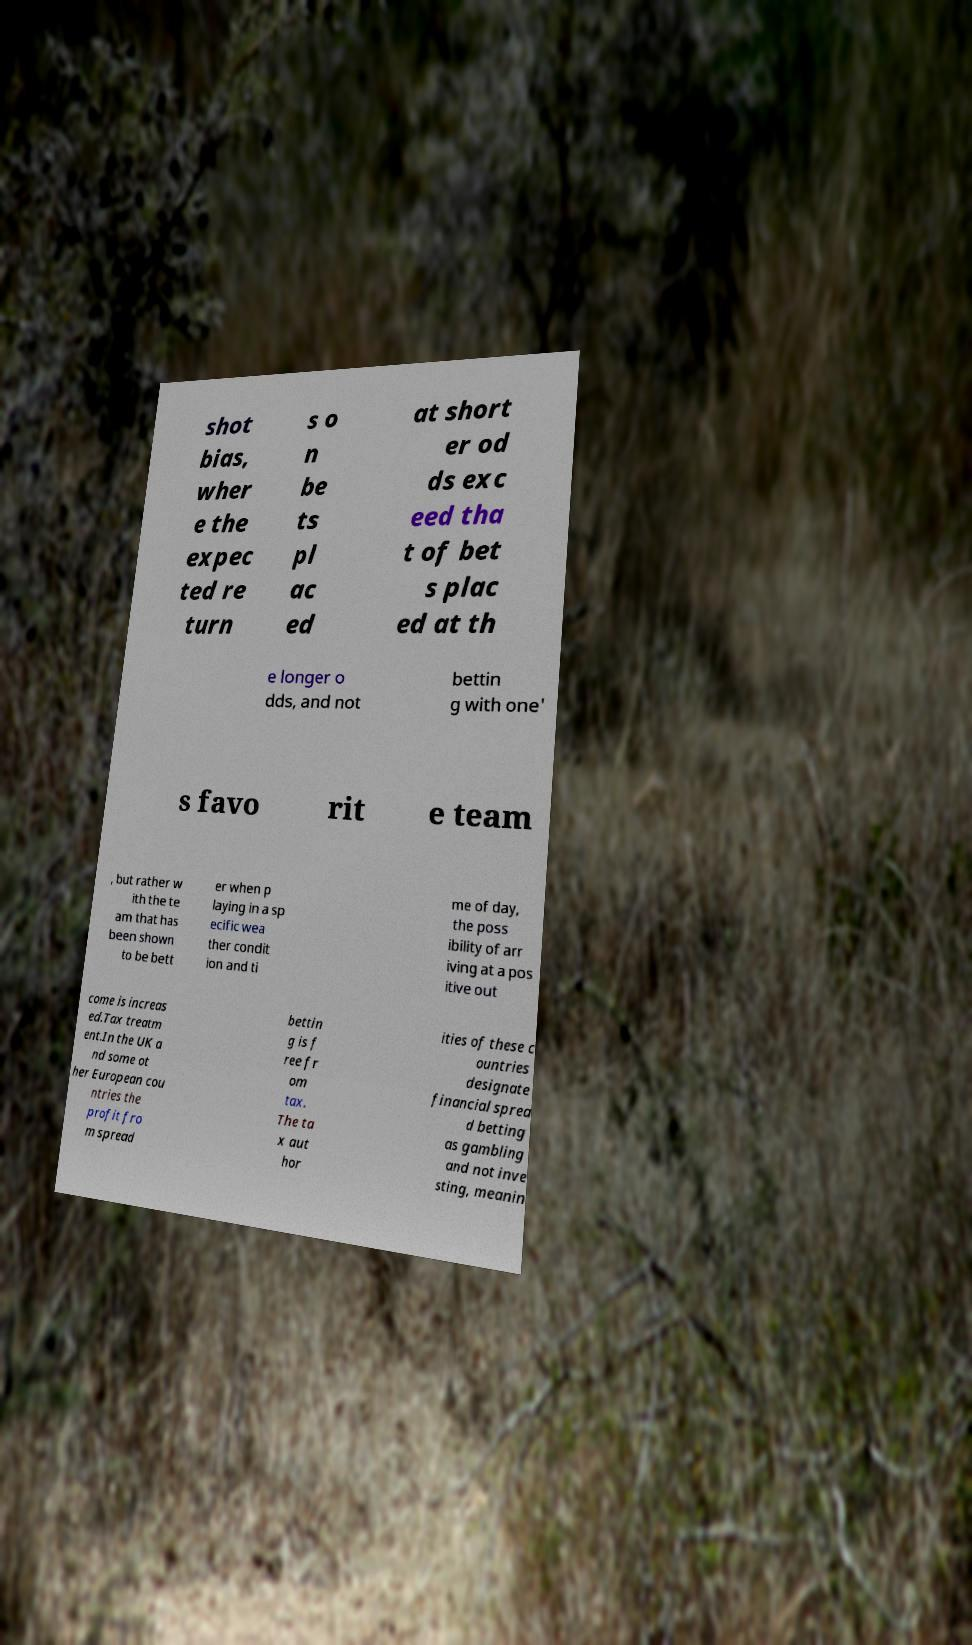Can you accurately transcribe the text from the provided image for me? shot bias, wher e the expec ted re turn s o n be ts pl ac ed at short er od ds exc eed tha t of bet s plac ed at th e longer o dds, and not bettin g with one' s favo rit e team , but rather w ith the te am that has been shown to be bett er when p laying in a sp ecific wea ther condit ion and ti me of day, the poss ibility of arr iving at a pos itive out come is increas ed.Tax treatm ent.In the UK a nd some ot her European cou ntries the profit fro m spread bettin g is f ree fr om tax. The ta x aut hor ities of these c ountries designate financial sprea d betting as gambling and not inve sting, meanin 